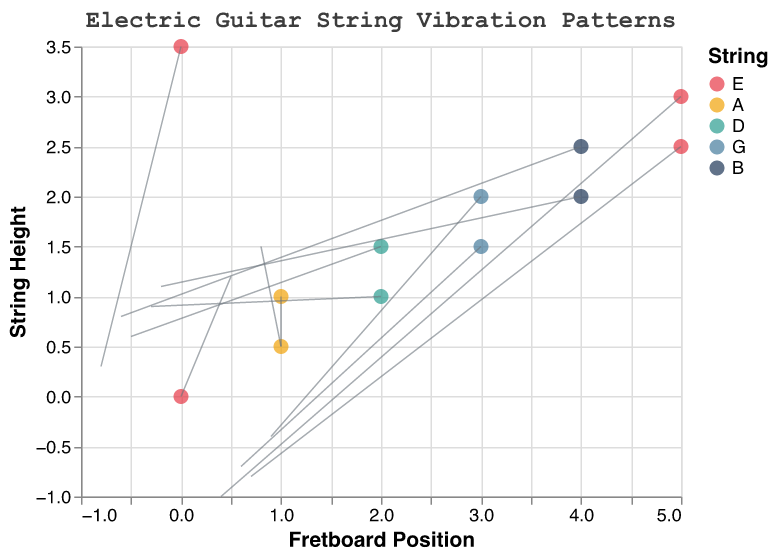What's the title of the plot? The plot's title is displayed prominently at the top. It reads "Electric Guitar String Vibration Patterns".
Answer: Electric Guitar String Vibration Patterns Which string has the most data points represented in the plot? To identify the string with the most data points, we count the occurrences of each string in the plot. The "E" string appears 4 times, while other strings appear fewer times.
Answer: E What are the x and y axis titles? The x-axis title and y-axis title are given on the plot. The x-axis title is "Fretboard Position", and the y-axis title is "String Height".
Answer: Fretboard Position, String Height What are the coordinates of the data point at fret position 5 on the D string? The plot shows the coordinates (x, y) for each combination of fret and string. The 5th fret on the D string has coordinates (2, 1).
Answer: (2, 1) Compare the lengths of vibration vectors for the 3rd fret on the A string and the 1st fret on the E string. Which one is longer? To compare the lengths of vectors, calculate the magnitude using the formula: sqrt(u^2 + v^2). For (3, A) with u=0.8 and v=1.5, it's sqrt(0.8^2 + 1.5^2) = 1.7. For (1, E) with u=0.5 and v=1.2, it's sqrt(0.5^2 + 1.2^2) = 1.3. The 3rd fret on the A string has a longer vector.
Answer: 3rd fret on the A string Which data point shows a downward vibration on the G string? A downward vibration on the G string means a negative value for v at some fret position on the G string. The plot shows the 7th fret has u=0.6 and v=-0.7, indicating a downward vibration.
Answer: 7th fret What is the color used to represent the B string? The legend on the plot shows the colors corresponding to each string. The B string is represented by the color navy blue.
Answer: navy blue What's the average 'y' position for the data points on the E string? To find the average, sum the y values of all E string data points and divide by their number. The y values are 0, 2.5, 3, 3.5. Sum = 9, and count = 4, so the average is 9/4.
Answer: 2.25 Between which fret positions on the E string does the highest positive u value occur? Checking the values on the E string, we look for the highest positive u. At position (0, 0) u=0.5; (5, 2.5) u=0.7; (5, 3) u=0.4; (0, 3.5) u=-0.8. The highest is 0.7 at the 12th fret.
Answer: Between the 12th fret What is the direction of the vibration vector at string height 2 for the G string? For the G string at string height 2 (y=2), the u and v values are 0.9 and -0.4 respectively. This indicates a vibration vector pointing right and slightly downwards.
Answer: Right and slightly downwards 